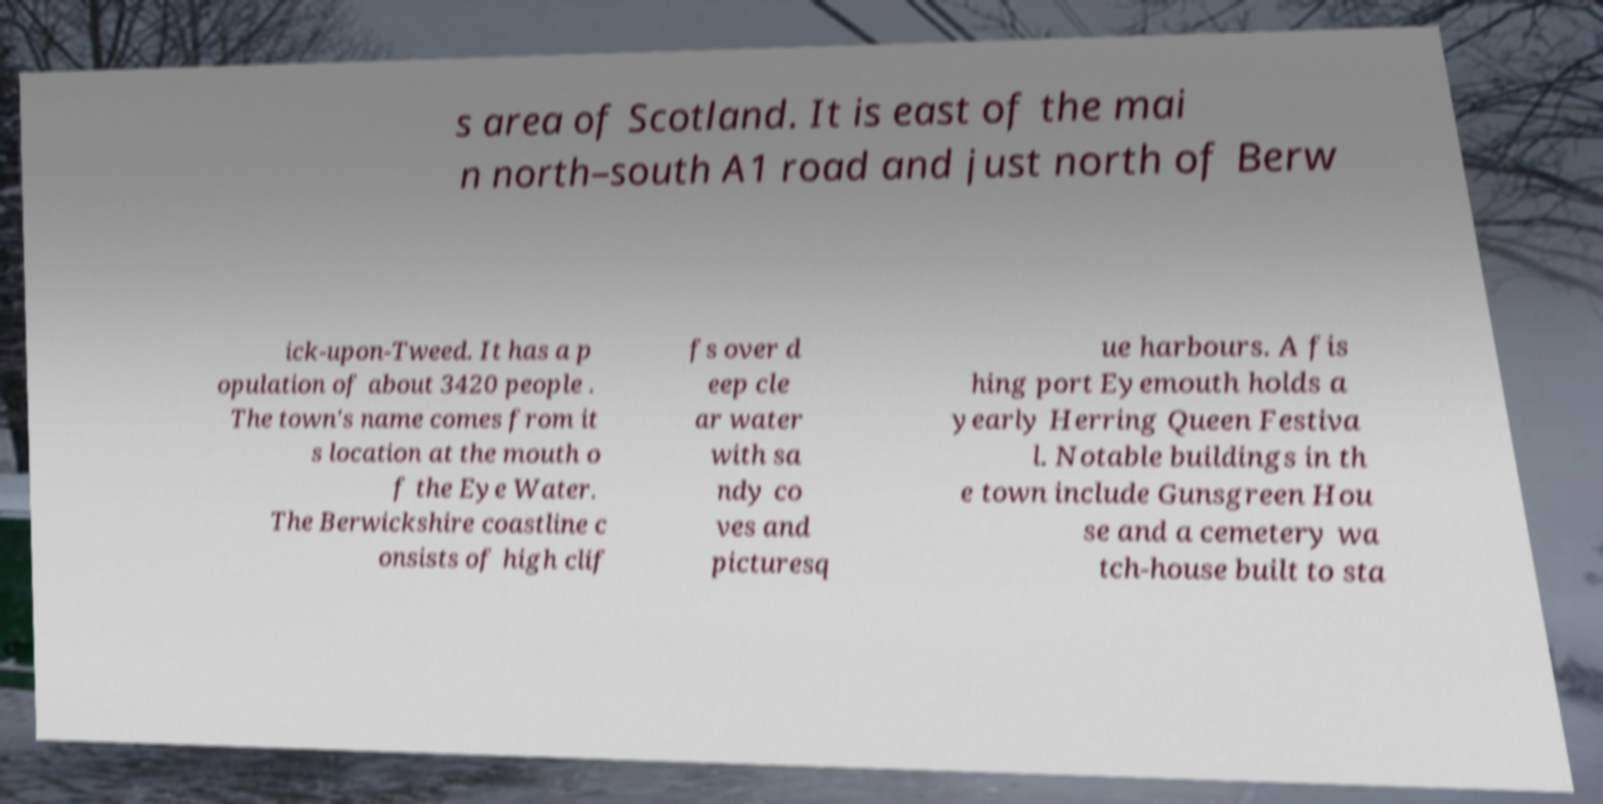Can you read and provide the text displayed in the image?This photo seems to have some interesting text. Can you extract and type it out for me? s area of Scotland. It is east of the mai n north–south A1 road and just north of Berw ick-upon-Tweed. It has a p opulation of about 3420 people . The town's name comes from it s location at the mouth o f the Eye Water. The Berwickshire coastline c onsists of high clif fs over d eep cle ar water with sa ndy co ves and picturesq ue harbours. A fis hing port Eyemouth holds a yearly Herring Queen Festiva l. Notable buildings in th e town include Gunsgreen Hou se and a cemetery wa tch-house built to sta 